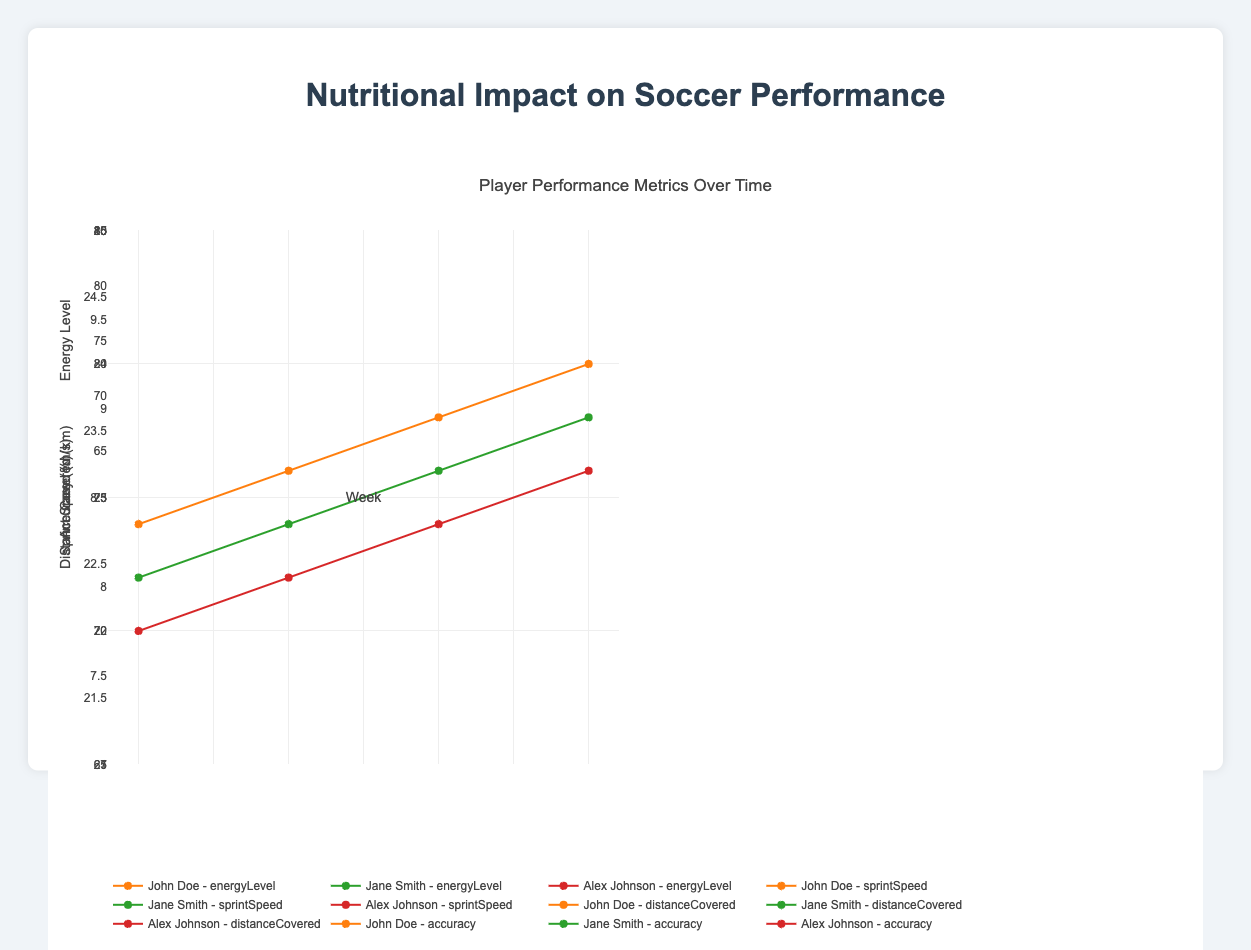What's the average sprint speed of John Doe over 4 weeks? John Doe's sprint speeds over 4 weeks are 23.1, 23.4, 23.7, and 24.0 m/s. The average is calculated by summing these values and dividing by the number of weeks: (23.1 + 23.4 + 23.7 + 24.0) / 4 = 23.55 m/s
Answer: 23.55 Which player had the highest energy level in the first week? The energy levels in the first week are 75 (John Doe), 70 (Jane Smith), and 68 (Alex Johnson). The highest energy level is 75, which belongs to John Doe
Answer: John Doe Between weeks 1 and 4, how much did Jane Smith improve her distance covered? Jane Smith's distance covered increased from 7.8 km in week 1 to 8.5 km in week 4. The improvement is calculated by subtracting the initial distance from the final distance: 8.5 - 7.8 = 0.7 km
Answer: 0.7 km Who had the greatest increase in sprint speed from week 1 to week 4? John Doe's sprint speed increased from 23.1 to 24.0 (0.9 m/s improvement), Jane Smith's sprint speed increased from 22.5 to 23.3 (0.8 m/s improvement), and Alex Johnson's sprint speed increased from 21.9 to 22.8 (0.9 m/s improvement). Both John Doe and Alex Johnson had the greatest increase of 0.9 m/s
Answer: John Doe and Alex Johnson Which player consistently had the lowest accuracy over the 4 weeks? By visually comparing the accuracy measures of each player over 4 weeks, Alex Johnson consistently had the lowest accuracy with values of 70, 72, 74, and 76 respectively
Answer: Alex Johnson What is the trend in energy levels for each player over the 4 weeks? John Doe's energy levels show an increasing trend from 75 to 82, Jane Smith's energy levels also show an increasing trend from 70 to 77, and Alex Johnson's energy levels increase from 68 to 74. All players have an upward trend in energy levels
Answer: Increasing trend for all players Comparing the final week, which player had the highest distance covered? In week 4, the distances covered are 9.3 km (John Doe), 8.5 km (Jane Smith), and 8.0 km (Alex Johnson). The highest distance covered is 9.3 km by John Doe
Answer: John Doe Is there a correlation between energy levels and sprint speed for any player? By visually inspecting the trend, we see that as the energy levels increase, the sprint speed also increases for each player. For John Doe, energy levels go from 75 to 82 while sprint speed goes from 23.1 to 24.0, indicating a positive correlation. Similar patterns are observed for Jane Smith and Alex Johnson. Therefore, there is a positive correlation for all players
Answer: Positive correlation 